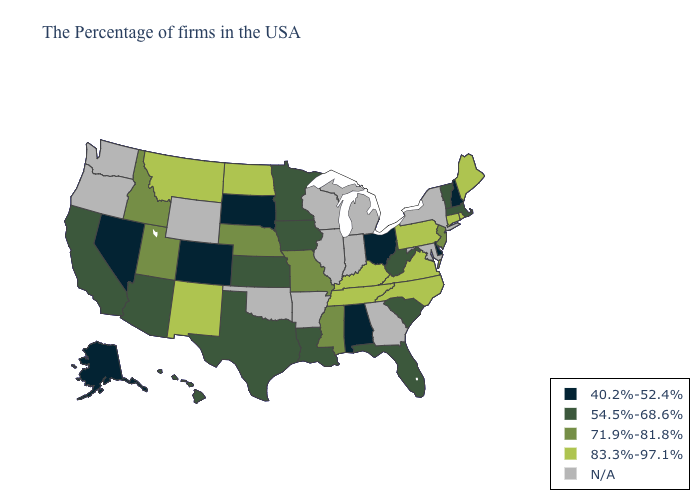What is the value of Florida?
Be succinct. 54.5%-68.6%. What is the highest value in the USA?
Write a very short answer. 83.3%-97.1%. Name the states that have a value in the range 71.9%-81.8%?
Short answer required. New Jersey, Mississippi, Missouri, Nebraska, Utah, Idaho. What is the highest value in the South ?
Answer briefly. 83.3%-97.1%. Which states have the highest value in the USA?
Give a very brief answer. Maine, Rhode Island, Connecticut, Pennsylvania, Virginia, North Carolina, Kentucky, Tennessee, North Dakota, New Mexico, Montana. Which states have the highest value in the USA?
Give a very brief answer. Maine, Rhode Island, Connecticut, Pennsylvania, Virginia, North Carolina, Kentucky, Tennessee, North Dakota, New Mexico, Montana. What is the value of Tennessee?
Keep it brief. 83.3%-97.1%. Which states hav the highest value in the South?
Answer briefly. Virginia, North Carolina, Kentucky, Tennessee. What is the lowest value in the MidWest?
Answer briefly. 40.2%-52.4%. Which states have the lowest value in the West?
Quick response, please. Colorado, Nevada, Alaska. Is the legend a continuous bar?
Write a very short answer. No. Does California have the lowest value in the West?
Concise answer only. No. What is the value of Montana?
Quick response, please. 83.3%-97.1%. 